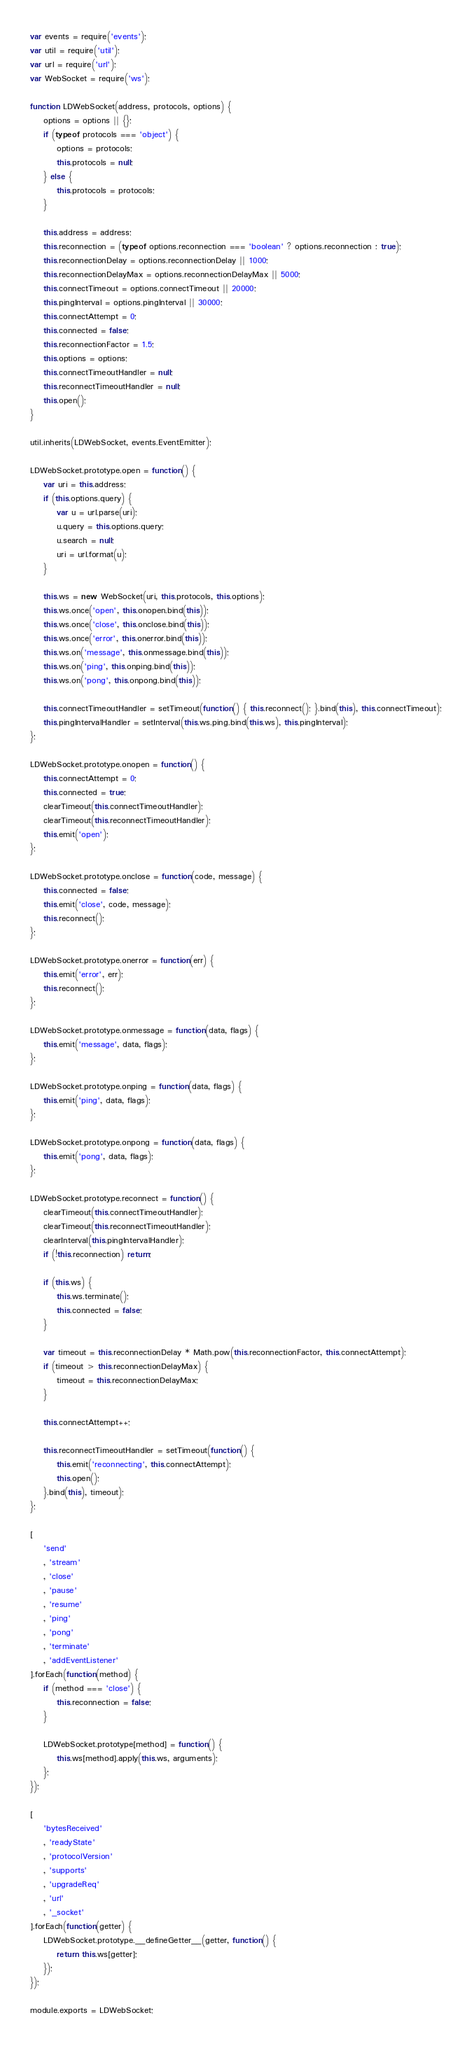Convert code to text. <code><loc_0><loc_0><loc_500><loc_500><_JavaScript_>var events = require('events');
var util = require('util');
var url = require('url');
var WebSocket = require('ws');

function LDWebSocket(address, protocols, options) {
    options = options || {};
    if (typeof protocols === 'object') {
        options = protocols;
        this.protocols = null;
    } else {
        this.protocols = protocols;
    }

    this.address = address;
    this.reconnection = (typeof options.reconnection === 'boolean' ? options.reconnection : true);
    this.reconnectionDelay = options.reconnectionDelay || 1000;
    this.reconnectionDelayMax = options.reconnectionDelayMax || 5000;
    this.connectTimeout = options.connectTimeout || 20000;
    this.pingInterval = options.pingInterval || 30000;
    this.connectAttempt = 0;
    this.connected = false;
    this.reconnectionFactor = 1.5;
    this.options = options;
    this.connectTimeoutHandler = null;
    this.reconnectTimeoutHandler = null;
    this.open();
}

util.inherits(LDWebSocket, events.EventEmitter);

LDWebSocket.prototype.open = function() {
    var uri = this.address;
    if (this.options.query) {
        var u = url.parse(uri);
        u.query = this.options.query;
        u.search = null;
        uri = url.format(u);
    }

    this.ws = new WebSocket(uri, this.protocols, this.options);
    this.ws.once('open', this.onopen.bind(this));
    this.ws.once('close', this.onclose.bind(this));
    this.ws.once('error', this.onerror.bind(this));
    this.ws.on('message', this.onmessage.bind(this));
    this.ws.on('ping', this.onping.bind(this));
    this.ws.on('pong', this.onpong.bind(this));

    this.connectTimeoutHandler = setTimeout(function() { this.reconnect(); }.bind(this), this.connectTimeout);
    this.pingIntervalHandler = setInterval(this.ws.ping.bind(this.ws), this.pingInterval);
};

LDWebSocket.prototype.onopen = function() {
    this.connectAttempt = 0;
    this.connected = true;
    clearTimeout(this.connectTimeoutHandler);
    clearTimeout(this.reconnectTimeoutHandler);
    this.emit('open');
};

LDWebSocket.prototype.onclose = function(code, message) {
    this.connected = false;
    this.emit('close', code, message);
    this.reconnect();
};

LDWebSocket.prototype.onerror = function(err) {
    this.emit('error', err);
    this.reconnect();
};

LDWebSocket.prototype.onmessage = function(data, flags) {
    this.emit('message', data, flags);
};

LDWebSocket.prototype.onping = function(data, flags) {
    this.emit('ping', data, flags);
};

LDWebSocket.prototype.onpong = function(data, flags) {
    this.emit('pong', data, flags);
};

LDWebSocket.prototype.reconnect = function() {
    clearTimeout(this.connectTimeoutHandler);
    clearTimeout(this.reconnectTimeoutHandler);
    clearInterval(this.pingIntervalHandler);
    if (!this.reconnection) return;

    if (this.ws) {
        this.ws.terminate();
        this.connected = false;
    }

    var timeout = this.reconnectionDelay * Math.pow(this.reconnectionFactor, this.connectAttempt);
    if (timeout > this.reconnectionDelayMax) {
        timeout = this.reconnectionDelayMax;
    }

    this.connectAttempt++;

    this.reconnectTimeoutHandler = setTimeout(function() {
        this.emit('reconnecting', this.connectAttempt);
        this.open();
    }.bind(this), timeout);
};

[
    'send'
    , 'stream'
    , 'close'
    , 'pause'
    , 'resume'
    , 'ping'
    , 'pong'
    , 'terminate'
    , 'addEventListener'
].forEach(function(method) {
    if (method === 'close') {
        this.reconnection = false;
    }

    LDWebSocket.prototype[method] = function() {
        this.ws[method].apply(this.ws, arguments);
    };
});

[
    'bytesReceived'
    , 'readyState'
    , 'protocolVersion'
    , 'supports'
    , 'upgradeReq'
    , 'url'
    , '_socket'
].forEach(function(getter) {
    LDWebSocket.prototype.__defineGetter__(getter, function() {
        return this.ws[getter];
    });
});

module.exports = LDWebSocket;
</code> 